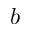<formula> <loc_0><loc_0><loc_500><loc_500>b</formula> 